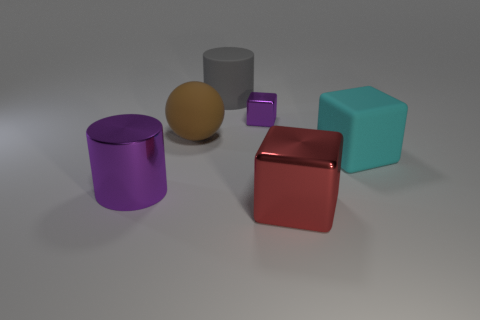How many objects in the scene have matte surfaces? There are three objects with matte surfaces: a purple cylinder, a teal cube, and a red cube. These objects diffuse light differently, resulting in a less shiny texture compared to the reflective surfaces of the gray cylinder and golden sphere. 